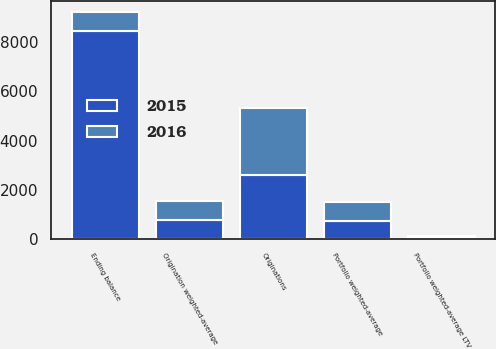<chart> <loc_0><loc_0><loc_500><loc_500><stacked_bar_chart><ecel><fcel>Ending balance<fcel>Portfolio weighted-average LTV<fcel>Portfolio weighted-average<fcel>Originations<fcel>Origination weighted-average<nl><fcel>2016<fcel>760<fcel>75<fcel>760<fcel>2717<fcel>775<nl><fcel>2015<fcel>8471<fcel>75<fcel>760<fcel>2606<fcel>774<nl></chart> 